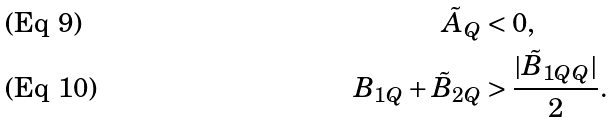<formula> <loc_0><loc_0><loc_500><loc_500>\tilde { A } _ { Q } & < 0 , \\ B _ { 1 Q } + \tilde { B } _ { 2 Q } & > \frac { | \tilde { B } _ { 1 Q Q } | } { 2 } .</formula> 